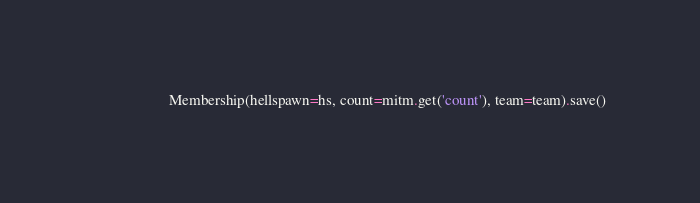Convert code to text. <code><loc_0><loc_0><loc_500><loc_500><_Python_>                    Membership(hellspawn=hs, count=mitm.get('count'), team=team).save()





</code> 